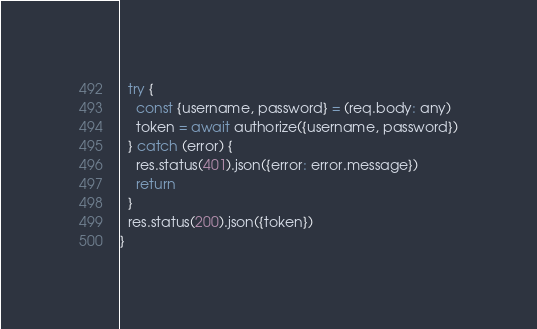Convert code to text. <code><loc_0><loc_0><loc_500><loc_500><_JavaScript_>  try {
    const {username, password} = (req.body: any)
    token = await authorize({username, password})
  } catch (error) {
    res.status(401).json({error: error.message})
    return
  }
  res.status(200).json({token})
}

</code> 